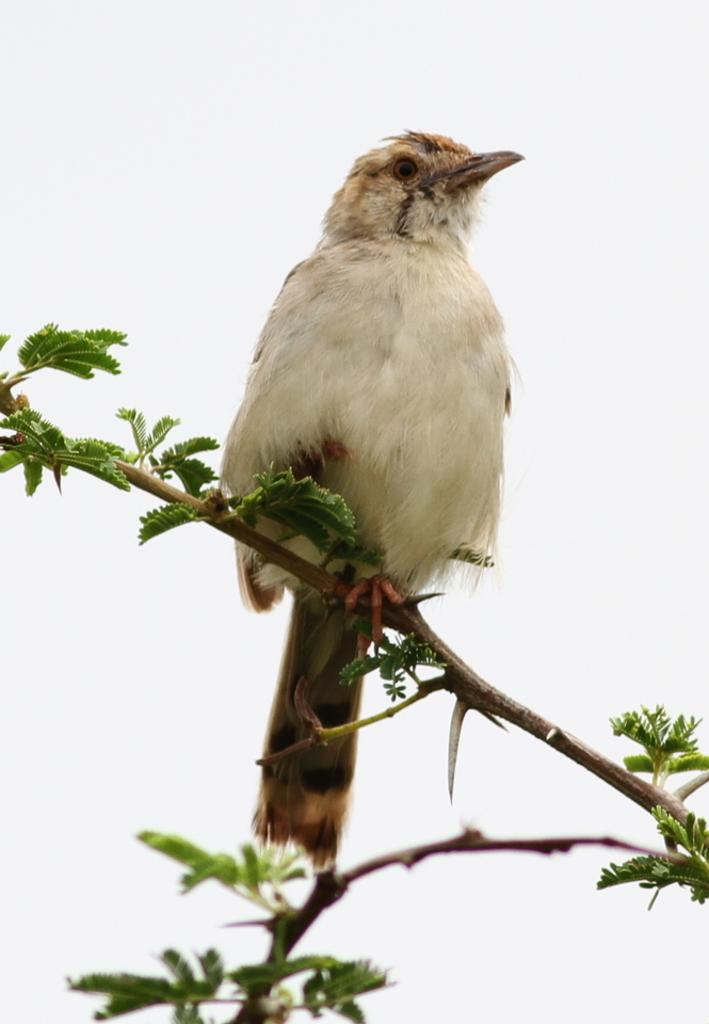What type of animal can be seen in the image? There is a bird in the image. Where is the bird located? The bird is on a wooden branch. What color is the background of the image? The background of the image is white. What type of pocket can be seen on the bird in the image? There is no pocket visible on the bird in the image. Can you tell me how many kitties are playing with the bird in the image? There are no kitties present in the image; it only features a bird on a wooden branch. 